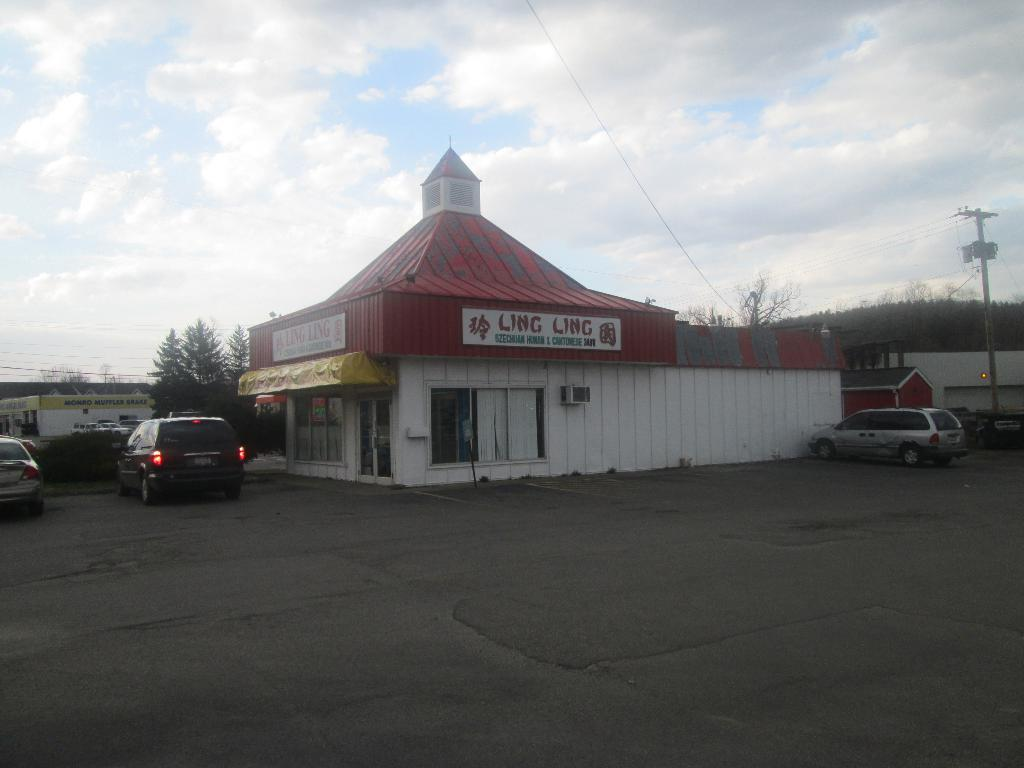What type of structure can be seen in the image? There is a building in the image. What other man-made structures are present in the image? There are sheds and a pole in the image. What vehicles can be seen in the image? There are cars in the image. What type of vegetation is present in the image? There are plants and trees in the image. What materials are visible in the image? There are boards in the image. What is the condition of the sky in the image? The sky is visible in the background of the image, and there are clouds in the sky. What surface can be used for transportation in the image? There is a road in the image. What grade does the building in the image represent? The grade of the building cannot be determined from the image. What beliefs are depicted in the image? There are no beliefs depicted in the image. What type of trousers are the trees wearing in the image? Trees do not wear trousers, as they are living organisms and not human beings. 